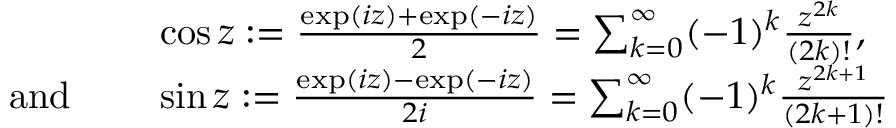Convert formula to latex. <formula><loc_0><loc_0><loc_500><loc_500>{ \begin{array} { r l } & { \cos z \colon = { \frac { \exp ( i z ) + \exp ( - i z ) } { 2 } } = \sum _ { k = 0 } ^ { \infty } ( - 1 ) ^ { k } { \frac { z ^ { 2 k } } { ( 2 k ) ! } } , } \\ { { a n d } \quad } & { \sin z \colon = { \frac { \exp ( i z ) - \exp ( - i z ) } { 2 i } } = \sum _ { k = 0 } ^ { \infty } ( - 1 ) ^ { k } { \frac { z ^ { 2 k + 1 } } { ( 2 k + 1 ) ! } } } \end{array} }</formula> 